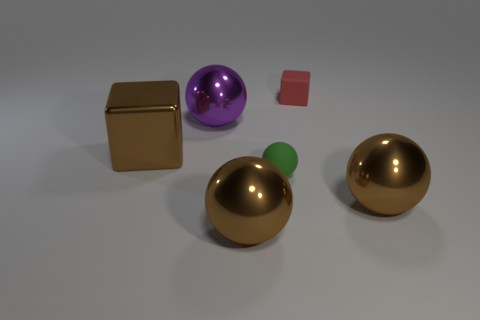Is there a big sphere of the same color as the big block? Yes, indeed there is a big sphere that shares the same golden hue as the large cube. 